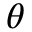<formula> <loc_0><loc_0><loc_500><loc_500>\theta</formula> 